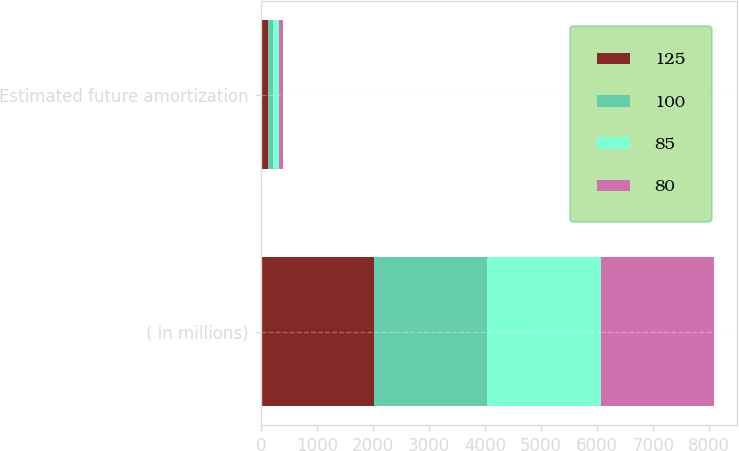<chart> <loc_0><loc_0><loc_500><loc_500><stacked_bar_chart><ecel><fcel>( in millions)<fcel>Estimated future amortization<nl><fcel>125<fcel>2019<fcel>125<nl><fcel>100<fcel>2020<fcel>100<nl><fcel>85<fcel>2021<fcel>95<nl><fcel>80<fcel>2022<fcel>85<nl></chart> 